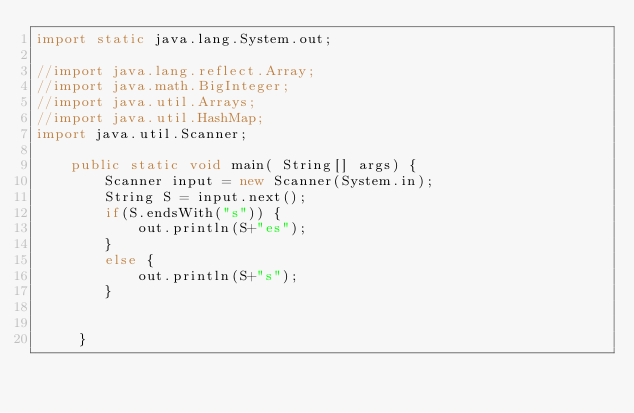Convert code to text. <code><loc_0><loc_0><loc_500><loc_500><_Java_>import static java.lang.System.out;

//import java.lang.reflect.Array;
//import java.math.BigInteger;
//import java.util.Arrays;
//import java.util.HashMap;
import java.util.Scanner;

    public static void main( String[] args) {
        Scanner input = new Scanner(System.in);
        String S = input.next();
        if(S.endsWith("s")) {
            out.println(S+"es");
        }
        else {
            out.println(S+"s");
        }


     }
</code> 